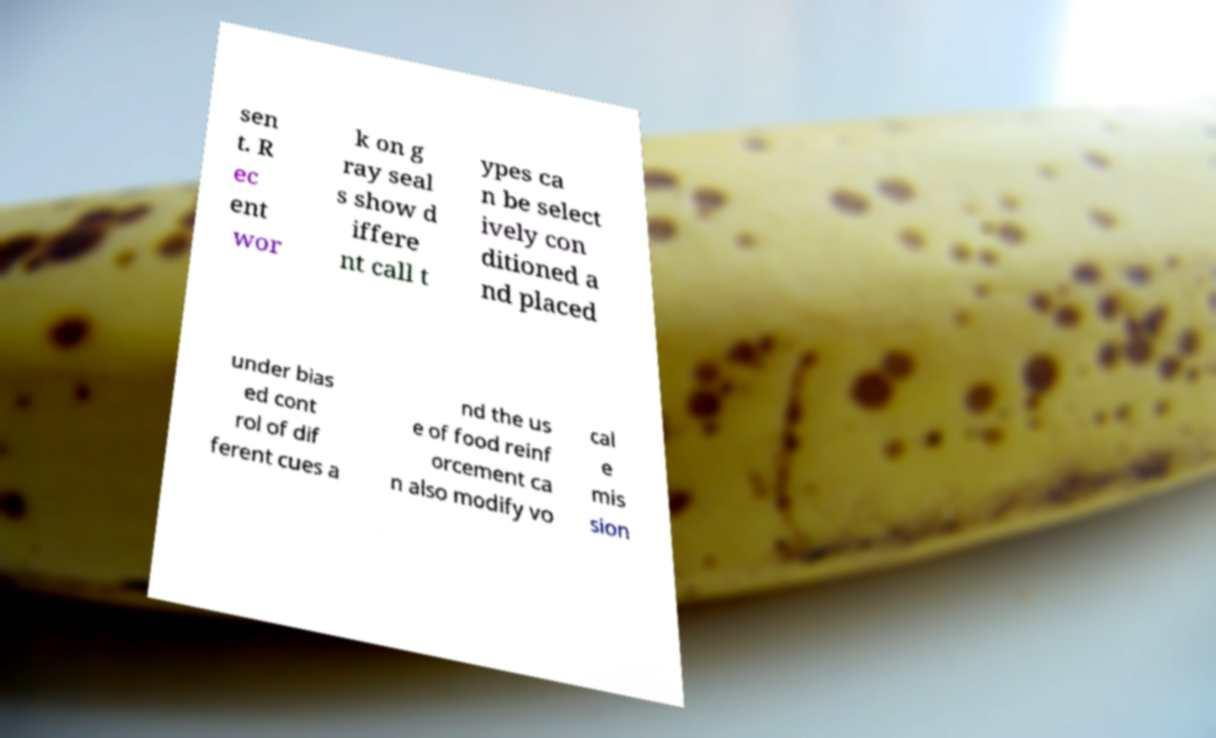Can you accurately transcribe the text from the provided image for me? sen t. R ec ent wor k on g ray seal s show d iffere nt call t ypes ca n be select ively con ditioned a nd placed under bias ed cont rol of dif ferent cues a nd the us e of food reinf orcement ca n also modify vo cal e mis sion 